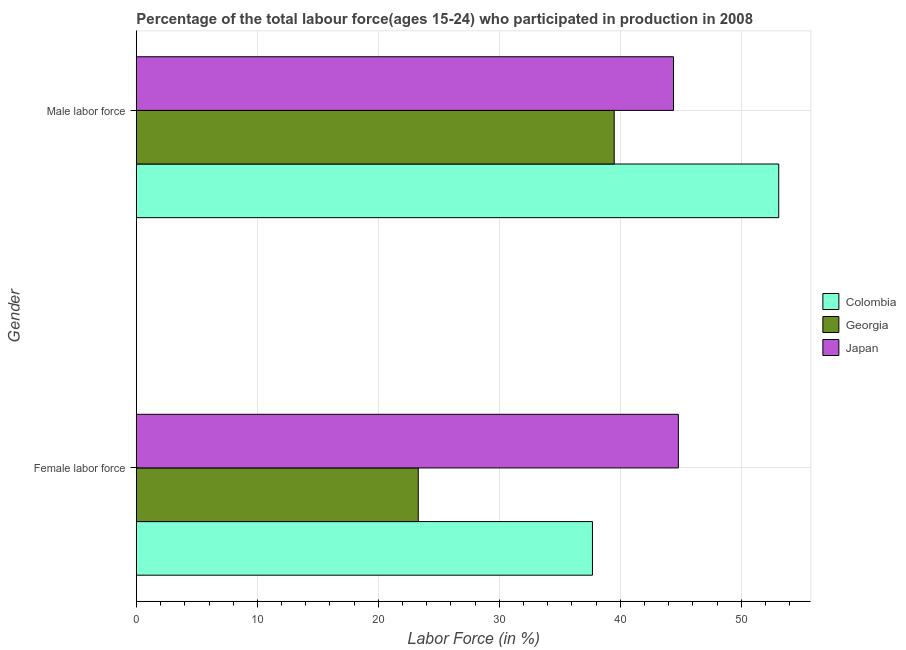What is the label of the 2nd group of bars from the top?
Ensure brevity in your answer.  Female labor force. What is the percentage of male labour force in Georgia?
Your answer should be compact. 39.5. Across all countries, what is the maximum percentage of female labor force?
Provide a short and direct response. 44.8. Across all countries, what is the minimum percentage of male labour force?
Give a very brief answer. 39.5. In which country was the percentage of male labour force maximum?
Give a very brief answer. Colombia. In which country was the percentage of female labor force minimum?
Your answer should be compact. Georgia. What is the total percentage of male labour force in the graph?
Make the answer very short. 137. What is the difference between the percentage of female labor force in Japan and that in Georgia?
Your response must be concise. 21.5. What is the difference between the percentage of female labor force in Georgia and the percentage of male labour force in Colombia?
Your answer should be compact. -29.8. What is the average percentage of female labor force per country?
Your answer should be very brief. 35.27. What is the difference between the percentage of female labor force and percentage of male labour force in Japan?
Ensure brevity in your answer.  0.4. In how many countries, is the percentage of male labour force greater than 46 %?
Your answer should be compact. 1. What is the ratio of the percentage of male labour force in Colombia to that in Japan?
Give a very brief answer. 1.2. Is the percentage of female labor force in Japan less than that in Colombia?
Keep it short and to the point. No. In how many countries, is the percentage of male labour force greater than the average percentage of male labour force taken over all countries?
Keep it short and to the point. 1. What does the 3rd bar from the top in Female labor force represents?
Give a very brief answer. Colombia. How many bars are there?
Your answer should be very brief. 6. How many countries are there in the graph?
Make the answer very short. 3. Are the values on the major ticks of X-axis written in scientific E-notation?
Your response must be concise. No. Does the graph contain grids?
Make the answer very short. Yes. How many legend labels are there?
Make the answer very short. 3. How are the legend labels stacked?
Ensure brevity in your answer.  Vertical. What is the title of the graph?
Your response must be concise. Percentage of the total labour force(ages 15-24) who participated in production in 2008. Does "Brunei Darussalam" appear as one of the legend labels in the graph?
Keep it short and to the point. No. What is the label or title of the X-axis?
Provide a short and direct response. Labor Force (in %). What is the label or title of the Y-axis?
Your answer should be compact. Gender. What is the Labor Force (in %) in Colombia in Female labor force?
Your response must be concise. 37.7. What is the Labor Force (in %) of Georgia in Female labor force?
Provide a short and direct response. 23.3. What is the Labor Force (in %) in Japan in Female labor force?
Keep it short and to the point. 44.8. What is the Labor Force (in %) of Colombia in Male labor force?
Ensure brevity in your answer.  53.1. What is the Labor Force (in %) of Georgia in Male labor force?
Offer a very short reply. 39.5. What is the Labor Force (in %) of Japan in Male labor force?
Offer a very short reply. 44.4. Across all Gender, what is the maximum Labor Force (in %) in Colombia?
Keep it short and to the point. 53.1. Across all Gender, what is the maximum Labor Force (in %) in Georgia?
Provide a succinct answer. 39.5. Across all Gender, what is the maximum Labor Force (in %) in Japan?
Make the answer very short. 44.8. Across all Gender, what is the minimum Labor Force (in %) in Colombia?
Your answer should be very brief. 37.7. Across all Gender, what is the minimum Labor Force (in %) of Georgia?
Offer a terse response. 23.3. Across all Gender, what is the minimum Labor Force (in %) in Japan?
Ensure brevity in your answer.  44.4. What is the total Labor Force (in %) in Colombia in the graph?
Your answer should be compact. 90.8. What is the total Labor Force (in %) of Georgia in the graph?
Your response must be concise. 62.8. What is the total Labor Force (in %) in Japan in the graph?
Give a very brief answer. 89.2. What is the difference between the Labor Force (in %) in Colombia in Female labor force and that in Male labor force?
Keep it short and to the point. -15.4. What is the difference between the Labor Force (in %) in Georgia in Female labor force and that in Male labor force?
Your answer should be compact. -16.2. What is the difference between the Labor Force (in %) of Japan in Female labor force and that in Male labor force?
Your answer should be very brief. 0.4. What is the difference between the Labor Force (in %) of Colombia in Female labor force and the Labor Force (in %) of Georgia in Male labor force?
Give a very brief answer. -1.8. What is the difference between the Labor Force (in %) of Colombia in Female labor force and the Labor Force (in %) of Japan in Male labor force?
Ensure brevity in your answer.  -6.7. What is the difference between the Labor Force (in %) of Georgia in Female labor force and the Labor Force (in %) of Japan in Male labor force?
Provide a short and direct response. -21.1. What is the average Labor Force (in %) in Colombia per Gender?
Make the answer very short. 45.4. What is the average Labor Force (in %) in Georgia per Gender?
Provide a short and direct response. 31.4. What is the average Labor Force (in %) of Japan per Gender?
Offer a very short reply. 44.6. What is the difference between the Labor Force (in %) in Colombia and Labor Force (in %) in Georgia in Female labor force?
Your answer should be very brief. 14.4. What is the difference between the Labor Force (in %) in Colombia and Labor Force (in %) in Japan in Female labor force?
Offer a very short reply. -7.1. What is the difference between the Labor Force (in %) in Georgia and Labor Force (in %) in Japan in Female labor force?
Offer a terse response. -21.5. What is the difference between the Labor Force (in %) in Colombia and Labor Force (in %) in Georgia in Male labor force?
Make the answer very short. 13.6. What is the difference between the Labor Force (in %) of Georgia and Labor Force (in %) of Japan in Male labor force?
Keep it short and to the point. -4.9. What is the ratio of the Labor Force (in %) in Colombia in Female labor force to that in Male labor force?
Make the answer very short. 0.71. What is the ratio of the Labor Force (in %) of Georgia in Female labor force to that in Male labor force?
Keep it short and to the point. 0.59. What is the difference between the highest and the second highest Labor Force (in %) of Colombia?
Your response must be concise. 15.4. What is the difference between the highest and the second highest Labor Force (in %) of Georgia?
Your answer should be very brief. 16.2. What is the difference between the highest and the second highest Labor Force (in %) in Japan?
Provide a short and direct response. 0.4. What is the difference between the highest and the lowest Labor Force (in %) in Colombia?
Ensure brevity in your answer.  15.4. What is the difference between the highest and the lowest Labor Force (in %) of Japan?
Your answer should be compact. 0.4. 